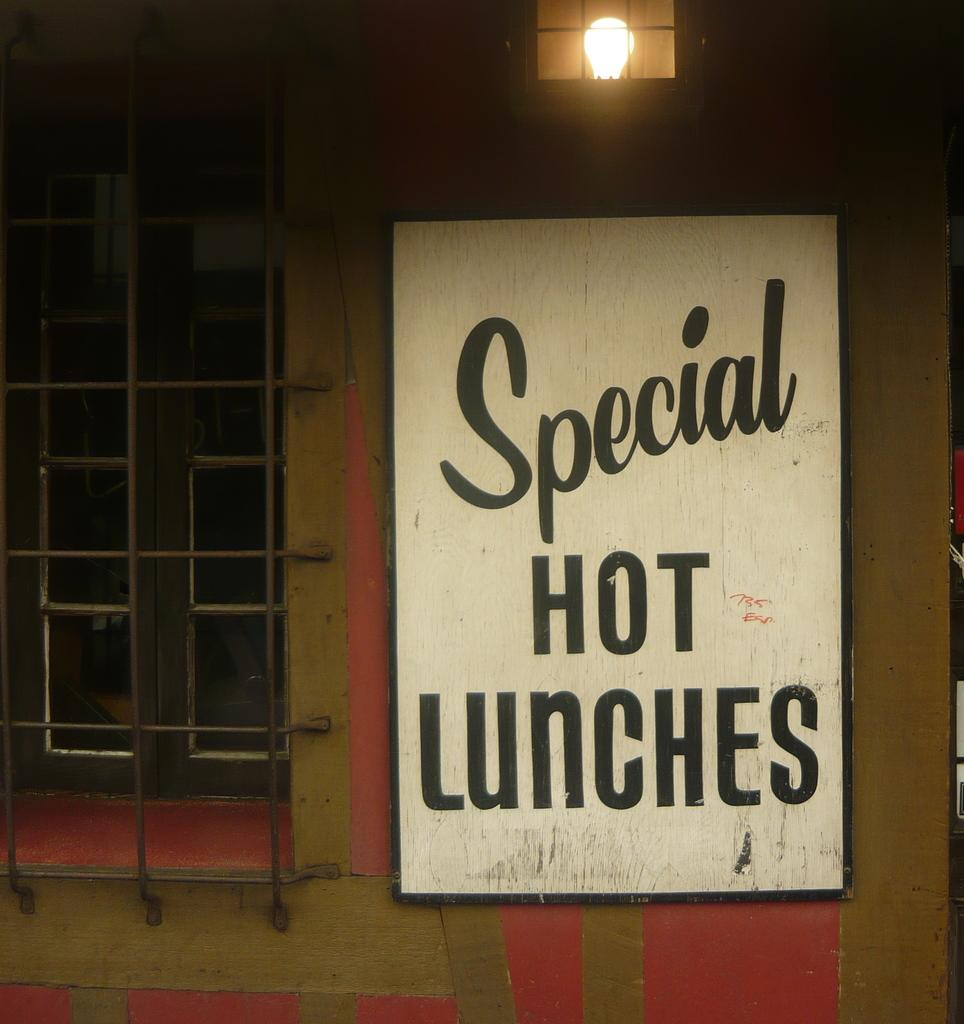What is on the wall in the image? There is a board with text on it on the wall in the image. What can be seen through the window in the image? The presence of a window in the image suggests that there might be a view or outdoor scene visible, but the specifics are not mentioned in the provided facts. What type of lighting is present in the image? There is a bulb in the image, which is a source of artificial light. What is the bulb protected by? The bulb has a metal grill for protection. Can you see any tomatoes growing near the window in the image? There is no mention of tomatoes or any plants in the image, so we cannot determine if they are present or not. How many people are jumping in the image? There is no indication of people or any jumping activity in the image. 